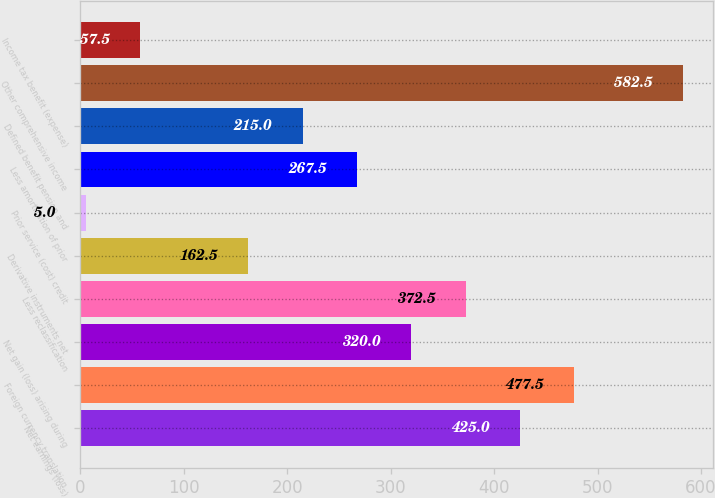<chart> <loc_0><loc_0><loc_500><loc_500><bar_chart><fcel>Net earnings (loss)<fcel>Foreign currency translation<fcel>Net gain (loss) arising during<fcel>Less reclassification<fcel>Derivative instruments net<fcel>Prior service (cost) credit<fcel>Less amortization of prior<fcel>Defined benefit pension and<fcel>Other comprehensive income<fcel>Income tax benefit (expense)<nl><fcel>425<fcel>477.5<fcel>320<fcel>372.5<fcel>162.5<fcel>5<fcel>267.5<fcel>215<fcel>582.5<fcel>57.5<nl></chart> 